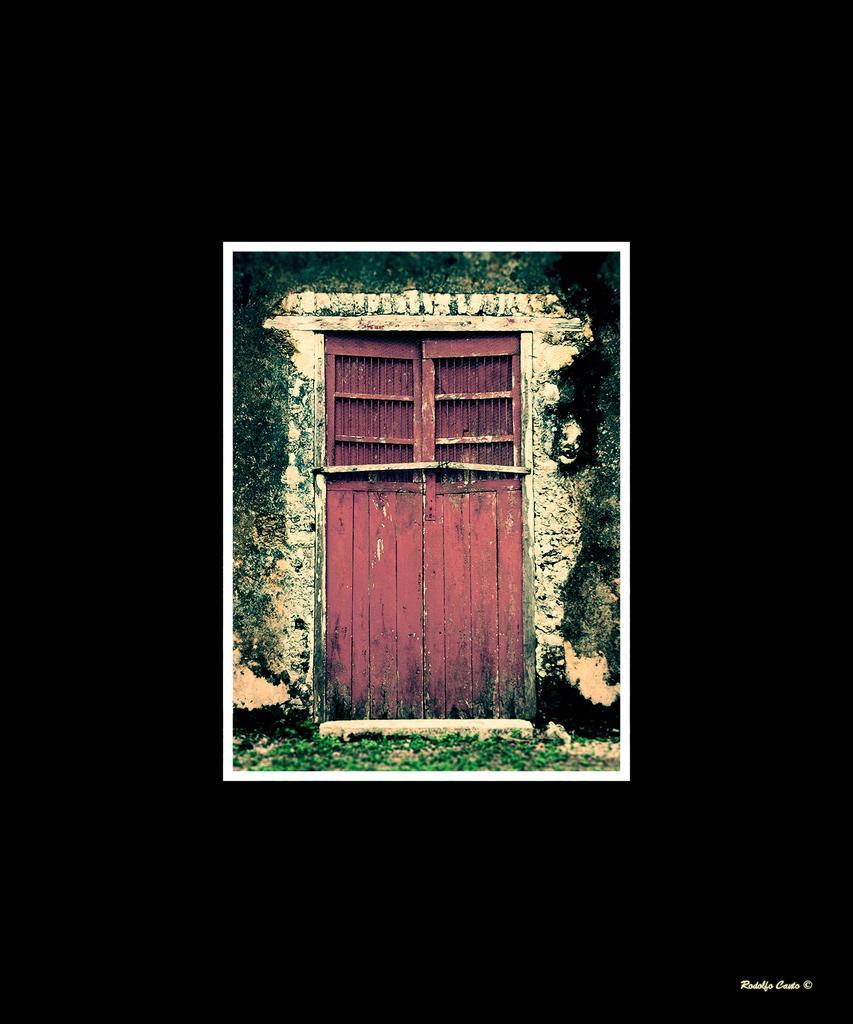Describe this image in one or two sentences. This image looks like an edited photo in which I can see a door, grass, creepers and house. 